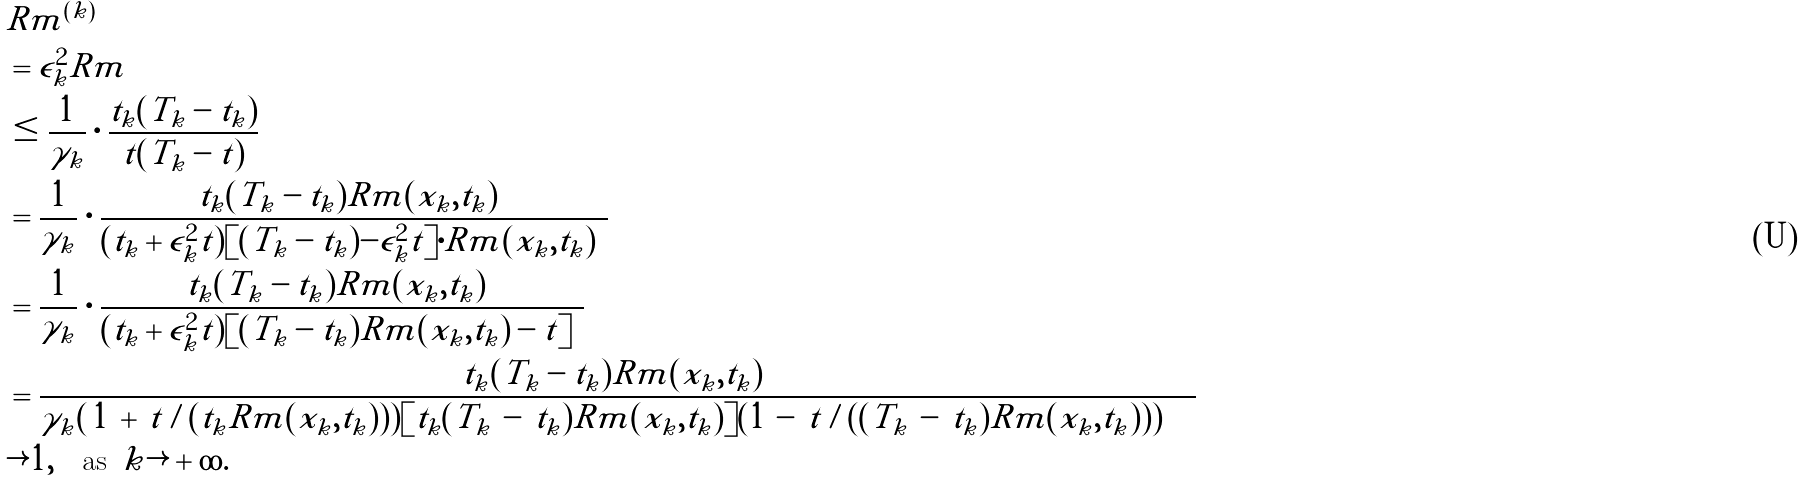<formula> <loc_0><loc_0><loc_500><loc_500>& | \tilde { R } m ^ { ( k ) } | \\ & = \epsilon _ { k } ^ { 2 } | R m | \\ & \leq \frac { 1 } { \gamma _ { k } } \cdot \frac { t _ { k } ( T _ { k } - t _ { k } ) } { t ( T _ { k } - t ) } \\ & = \frac { 1 } { \gamma _ { k } } \cdot \frac { t _ { k } ( T _ { k } - t _ { k } ) | R m ( x _ { k } , t _ { k } ) | } { ( t _ { k } + \epsilon _ { k } ^ { 2 } \tilde { t } ) [ ( T _ { k } - t _ { k } ) - \epsilon _ { k } ^ { 2 } \tilde { t } ] \cdot | R m ( x _ { k } , t _ { k } ) | } \\ & = \frac { 1 } { \gamma _ { k } } \cdot \frac { t _ { k } ( T _ { k } - t _ { k } ) | R m ( x _ { k } , t _ { k } ) | } { ( t _ { k } + \epsilon _ { k } ^ { 2 } \tilde { t } ) [ ( T _ { k } - t _ { k } ) | R m ( x _ { k } , t _ { k } ) | - \tilde { t } ] } \\ & = \frac { t _ { k } ( T _ { k } - t _ { k } ) | R m ( x _ { k } , t _ { k } ) | } { \gamma _ { k } ( \, 1 \, + \, \tilde { t } / ( t _ { k } | R m ( x _ { k } , t _ { k } ) | ) ) [ t _ { k } ( T _ { k } \, - \, t _ { k } ) | R m ( x _ { k } , t _ { k } ) | ] ( 1 \, - \, \tilde { t } / ( ( T _ { k } \, - \, t _ { k } ) | R m ( x _ { k } , t _ { k } ) | ) ) } \\ & \rightarrow 1 , \quad \text {as } \, k \rightarrow + \infty .</formula> 